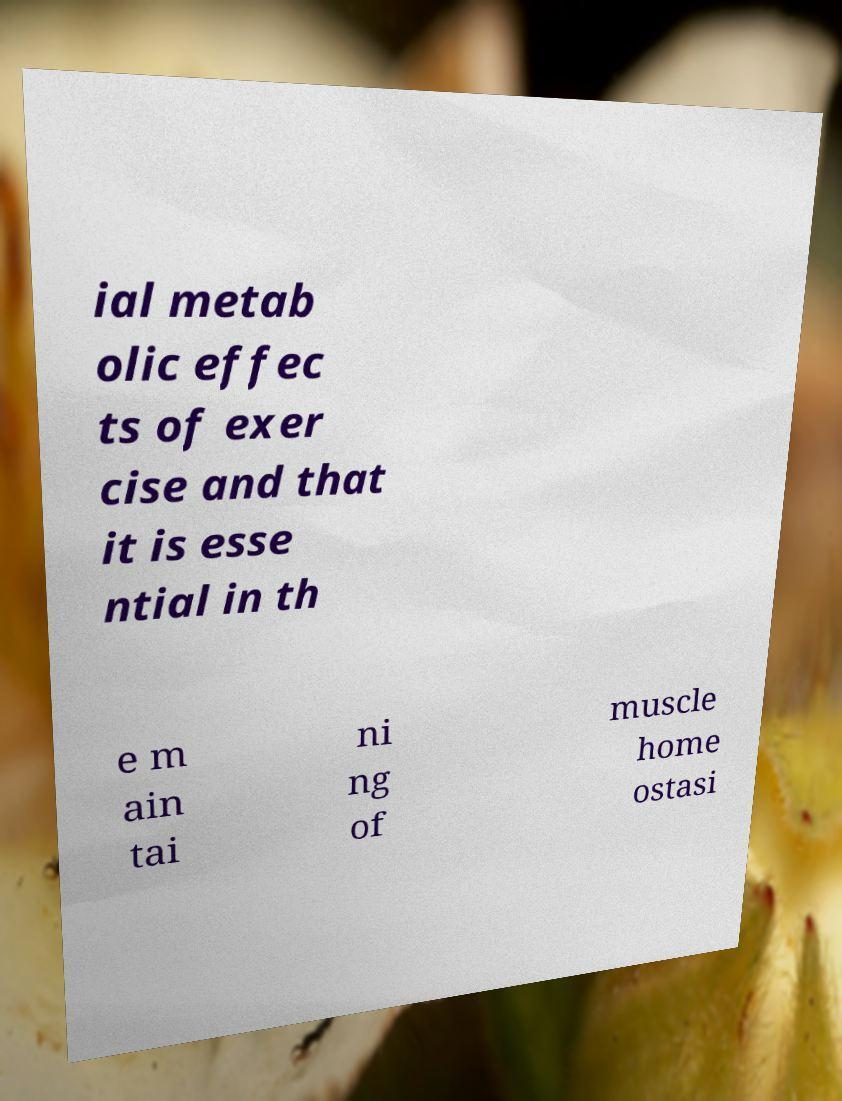Could you extract and type out the text from this image? ial metab olic effec ts of exer cise and that it is esse ntial in th e m ain tai ni ng of muscle home ostasi 